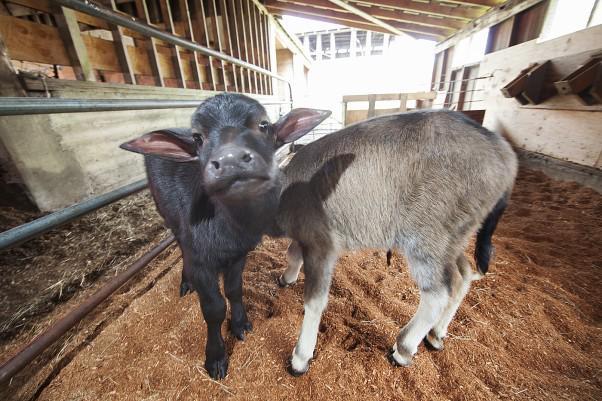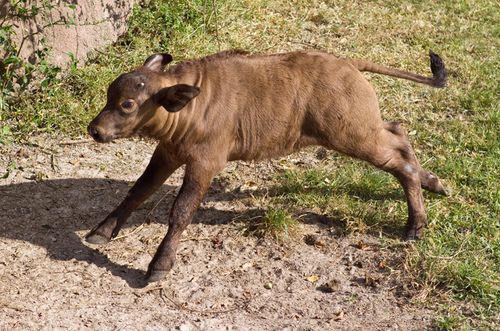The first image is the image on the left, the second image is the image on the right. Analyze the images presented: Is the assertion "There is exactly one animal in the image on the right." valid? Answer yes or no. Yes. The first image is the image on the left, the second image is the image on the right. Evaluate the accuracy of this statement regarding the images: "There is water visible in at least one of the images.". Is it true? Answer yes or no. No. 